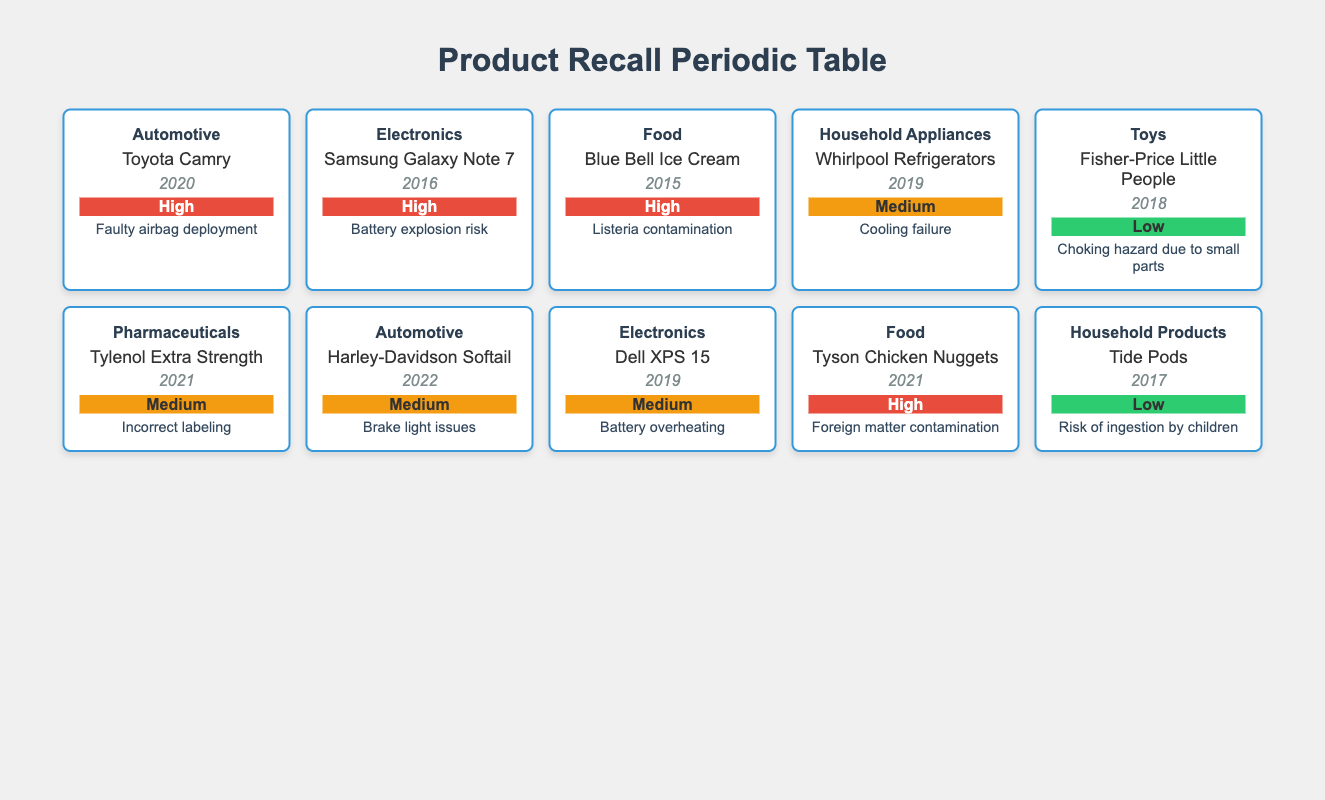What is the product recalled due to faulty airbag deployment? The table contains a recall incident for the "Toyota Camry" in the automotive category in 2020, specifically due to faulty airbag deployment.
Answer: Toyota Camry How many products were recalled in the "Food" category? There are three products listed in the "Food" category: "Blue Bell Ice Cream," "Tyson Chicken Nuggets," and "Tyson Chicken Nuggets." Therefore, the total count of recalled products is 3.
Answer: 3 What is the most recent recall year for a "pharmaceutical" category product? The "pharmaceutical" category has one entry for "Tylenol Extra Strength," which was recalled in 2021, making it the most recent recall year for this category.
Answer: 2021 Did the "Samsung Galaxy Note 7" have a high severity rating? Yes, the severity rating for the "Samsung Galaxy Note 7" recall in 2016 is classified as high due to the risk of battery explosion.
Answer: Yes Which product had a recall due to incorrect labeling, and what was its severity? The product recalled due to incorrect labeling is "Tylenol Extra Strength," which falls under the pharmaceutical category and has a medium severity rating as per the table.
Answer: Tylenol Extra Strength, Medium Severity How many products were recalled between 2015 and 2021 with high severity? The products recalled with high severity during this period are "Blue Bell Ice Cream" (2015), "Samsung Galaxy Note 7" (2016), "Tyson Chicken Nuggets" (2021), and "Toyota Camry" (2020), making a total of four products.
Answer: 4 What is the relationship between product category and severity for "Tide Pods"? The "Tide Pods" product, recalled in 2017, belongs to the "Household Products" category and has a low severity rating due to the risk of ingestion by children, indicating a less critical hazard compared to other incidents.
Answer: Tide Pods, Low Severity Which category had both high and medium severity recalls? The automotive category had products with both high severity (Toyota Camry) and medium severity (Harley-Davidson Softail). This illustrates the range of severity classifications within the same category.
Answer: Automotive What percentage of total recalls are classified as high severity? There are 10 total recalls listed in the table, 4 of which are classified as high severity (Toyota Camry, Samsung Galaxy Note 7, Blue Bell Ice Cream, Tyson Chicken Nuggets). Thus, the percentage of high severity recalls is (4 / 10) * 100 = 40%.
Answer: 40% 